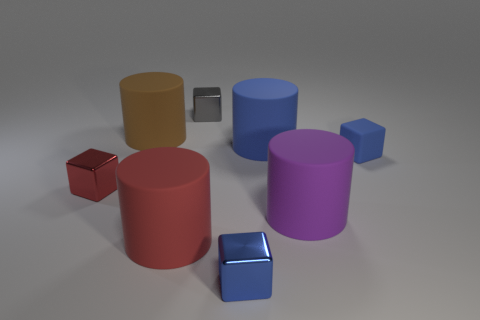Subtract 1 cylinders. How many cylinders are left? 3 Add 1 small blue cubes. How many objects exist? 9 Subtract 1 brown cylinders. How many objects are left? 7 Subtract all small gray blocks. Subtract all large purple things. How many objects are left? 6 Add 6 large red matte things. How many large red matte things are left? 7 Add 5 blue rubber cylinders. How many blue rubber cylinders exist? 6 